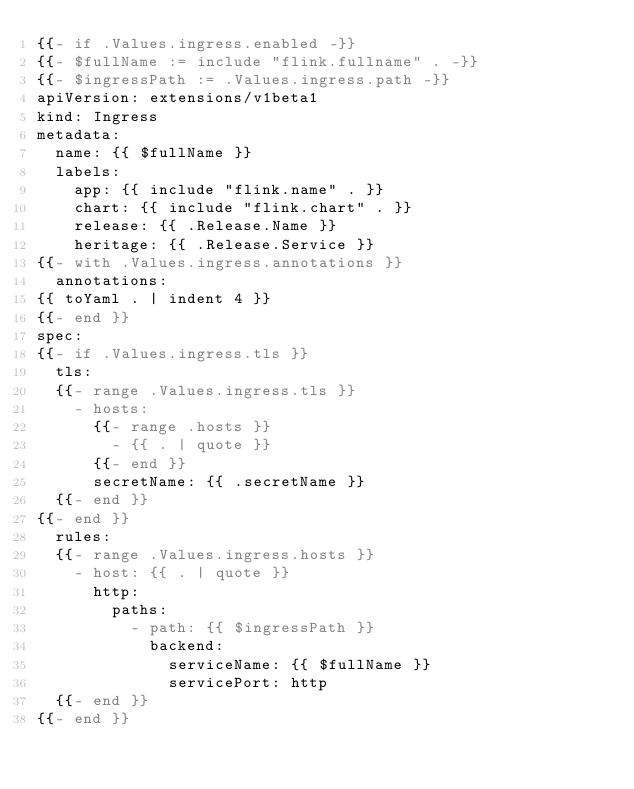Convert code to text. <code><loc_0><loc_0><loc_500><loc_500><_YAML_>{{- if .Values.ingress.enabled -}}
{{- $fullName := include "flink.fullname" . -}}
{{- $ingressPath := .Values.ingress.path -}}
apiVersion: extensions/v1beta1
kind: Ingress
metadata:
  name: {{ $fullName }}
  labels:
    app: {{ include "flink.name" . }}
    chart: {{ include "flink.chart" . }}
    release: {{ .Release.Name }}
    heritage: {{ .Release.Service }}
{{- with .Values.ingress.annotations }}
  annotations:
{{ toYaml . | indent 4 }}
{{- end }}
spec:
{{- if .Values.ingress.tls }}
  tls:
  {{- range .Values.ingress.tls }}
    - hosts:
      {{- range .hosts }}
        - {{ . | quote }}
      {{- end }}
      secretName: {{ .secretName }}
  {{- end }}
{{- end }}
  rules:
  {{- range .Values.ingress.hosts }}
    - host: {{ . | quote }}
      http:
        paths:
          - path: {{ $ingressPath }}
            backend:
              serviceName: {{ $fullName }}
              servicePort: http
  {{- end }}
{{- end }}
</code> 